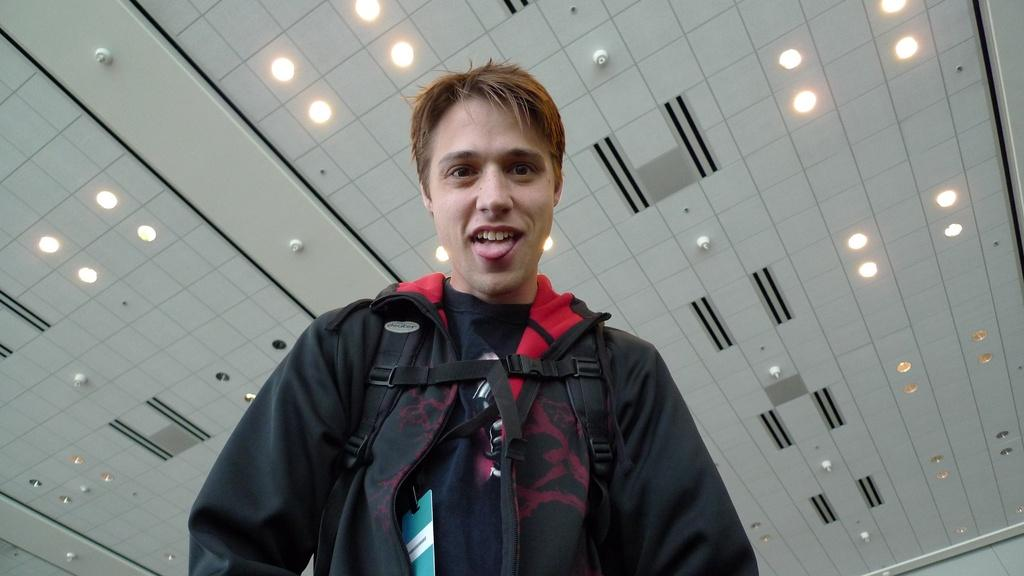Who is the main subject in the picture? There is a boy in the picture. What is the boy wearing? The boy is wearing a black jacket. Where is the boy positioned in the image? The boy is standing in the front. What is the boy's facial expression? The boy is smiling. What can be seen above the boy in the picture? There is a ceiling in the picture. What is providing illumination in the image? There are lights visible in the picture. What type of committee is meeting in the picture? There is no committee meeting in the picture; it features a boy standing in the front. How many people are present in the crowd in the picture? There is no crowd present in the picture; it only shows a boy standing in the front. 